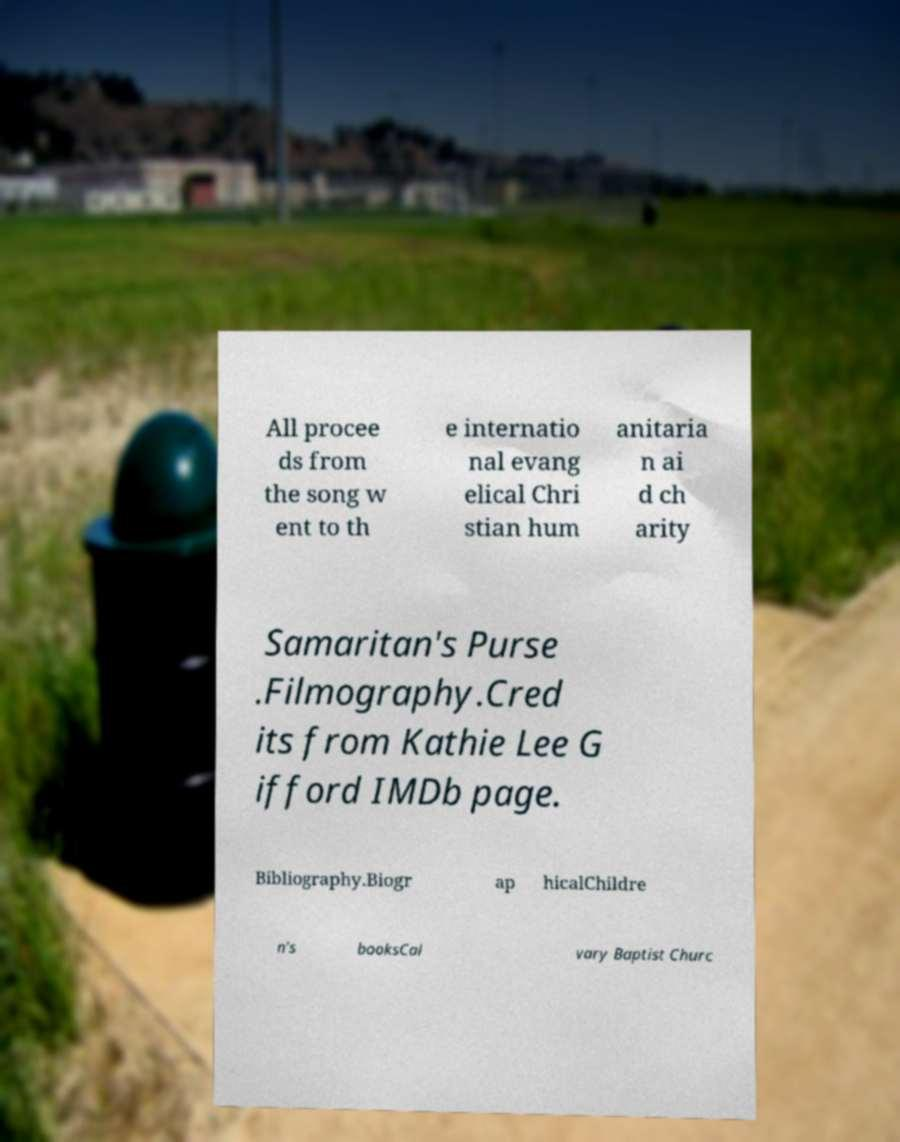I need the written content from this picture converted into text. Can you do that? All procee ds from the song w ent to th e internatio nal evang elical Chri stian hum anitaria n ai d ch arity Samaritan's Purse .Filmography.Cred its from Kathie Lee G ifford IMDb page. Bibliography.Biogr ap hicalChildre n's booksCal vary Baptist Churc 